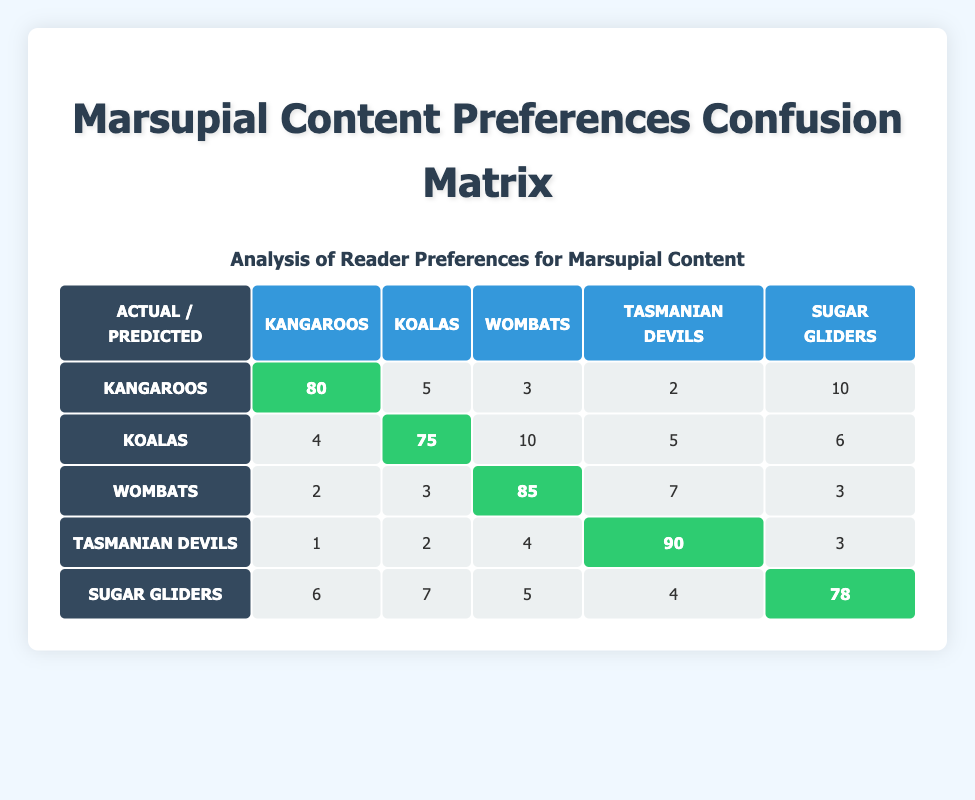What is the predicted preference for Kangaroos? According to the confusion matrix, the predicted preference for Kangaroos is found in the first row under the heading for Kangaroos, which shows 80.
Answer: 80 What is the total number of responses for Koalas? To find the total number of responses for Koalas, sum all values in the Koalas column: 4 (Kangaroos) + 75 (Koalas) + 10 (Wombats) + 5 (Tasmanian Devils) + 6 (Sugar Gliders) = 100.
Answer: 100 Are more readers interested in Wombats than Sugar Gliders? Comparing the diagonal values, Wombats received 85 while Sugar Gliders received 78, thus more readers are interested in Wombats than Sugar Gliders.
Answer: Yes What is the difference in predicted preferences between Tasmanian Devils and Wombats? The predicted preference for Tasmanian Devils is 90 and for Wombats is 85. The difference is calculated by subtracting the two values: 90 - 85 = 5.
Answer: 5 What percentage of readers preferred Sugar Gliders compared to the total number of responses? First, calculate the total responses: 80 + 5 + 3 + 2 + 10 + 4 + 75 + 10 + 5 + 6 + 2 + 3 + 85 + 7 + 3 + 1 + 2 + 4 + 90 + 3 + 6 + 7 + 5 + 4 + 78 = 383. Of those, 78 preferred Sugar Gliders. Thus, the percentage is (78 / 383) * 100 ≈ 20.4%.
Answer: Approximately 20.4% What is the most commonly preferred marsupial based on the actual preferences? Looking for the highest value in the diagonal of the confusion matrix, we see Kangaroos has 80, Koalas has 75, Wombats has 85, Tasmanian Devils has 90, and Sugar Gliders has 78. The highest value is 90 for Tasmanian Devils.
Answer: Tasmanian Devils 